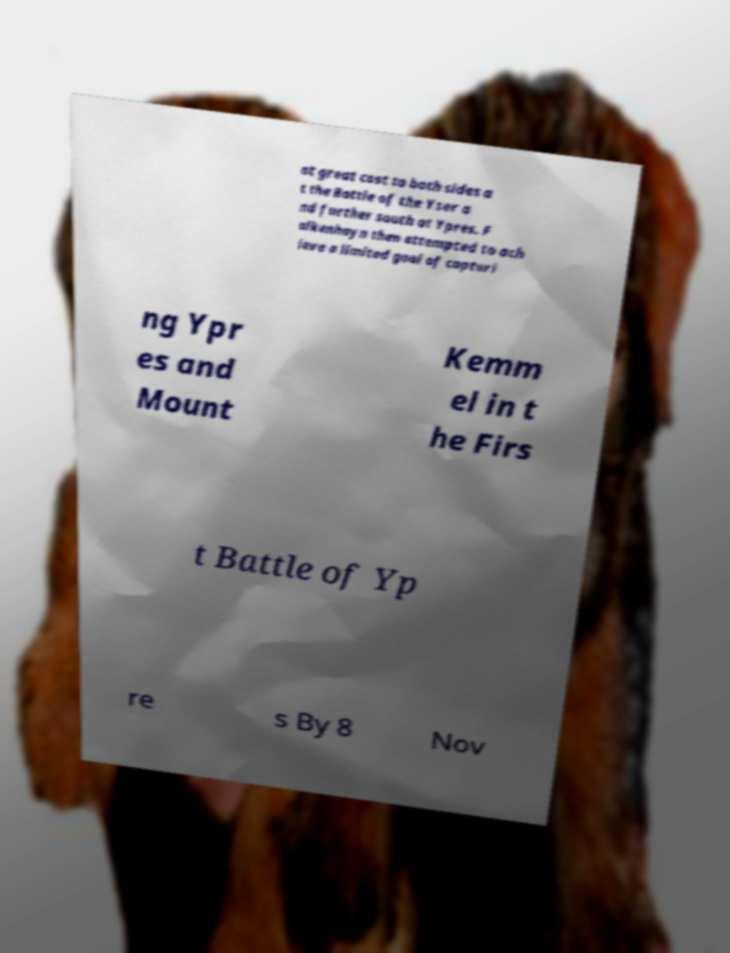For documentation purposes, I need the text within this image transcribed. Could you provide that? at great cost to both sides a t the Battle of the Yser a nd further south at Ypres. F alkenhayn then attempted to ach ieve a limited goal of capturi ng Ypr es and Mount Kemm el in t he Firs t Battle of Yp re s By 8 Nov 